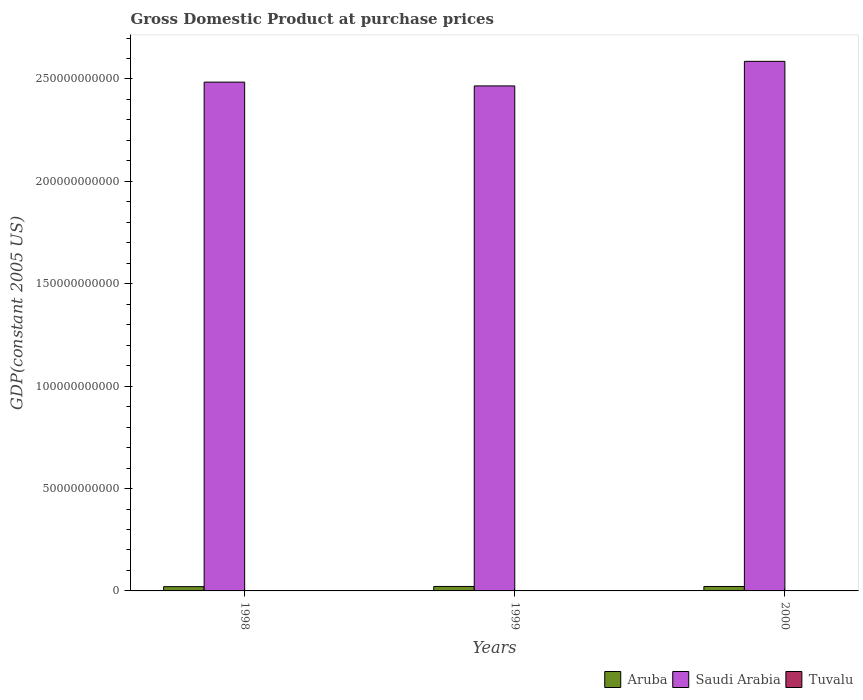What is the GDP at purchase prices in Saudi Arabia in 1998?
Offer a terse response. 2.48e+11. Across all years, what is the maximum GDP at purchase prices in Aruba?
Your response must be concise. 2.18e+09. Across all years, what is the minimum GDP at purchase prices in Aruba?
Give a very brief answer. 2.09e+09. What is the total GDP at purchase prices in Saudi Arabia in the graph?
Provide a succinct answer. 7.54e+11. What is the difference between the GDP at purchase prices in Aruba in 1998 and that in 1999?
Offer a terse response. -9.41e+07. What is the difference between the GDP at purchase prices in Saudi Arabia in 2000 and the GDP at purchase prices in Tuvalu in 1999?
Provide a succinct answer. 2.59e+11. What is the average GDP at purchase prices in Saudi Arabia per year?
Offer a terse response. 2.51e+11. In the year 1999, what is the difference between the GDP at purchase prices in Tuvalu and GDP at purchase prices in Saudi Arabia?
Your answer should be very brief. -2.47e+11. In how many years, is the GDP at purchase prices in Tuvalu greater than 110000000000 US$?
Provide a short and direct response. 0. What is the ratio of the GDP at purchase prices in Saudi Arabia in 1998 to that in 1999?
Make the answer very short. 1.01. Is the GDP at purchase prices in Aruba in 1999 less than that in 2000?
Offer a terse response. No. Is the difference between the GDP at purchase prices in Tuvalu in 1998 and 2000 greater than the difference between the GDP at purchase prices in Saudi Arabia in 1998 and 2000?
Give a very brief answer. Yes. What is the difference between the highest and the second highest GDP at purchase prices in Aruba?
Keep it short and to the point. 7.95e+06. What is the difference between the highest and the lowest GDP at purchase prices in Saudi Arabia?
Keep it short and to the point. 1.20e+1. In how many years, is the GDP at purchase prices in Aruba greater than the average GDP at purchase prices in Aruba taken over all years?
Provide a succinct answer. 2. What does the 3rd bar from the left in 1998 represents?
Your response must be concise. Tuvalu. What does the 2nd bar from the right in 2000 represents?
Offer a very short reply. Saudi Arabia. Is it the case that in every year, the sum of the GDP at purchase prices in Aruba and GDP at purchase prices in Saudi Arabia is greater than the GDP at purchase prices in Tuvalu?
Provide a short and direct response. Yes. How many years are there in the graph?
Give a very brief answer. 3. Are the values on the major ticks of Y-axis written in scientific E-notation?
Your answer should be compact. No. Does the graph contain grids?
Give a very brief answer. No. How are the legend labels stacked?
Offer a very short reply. Horizontal. What is the title of the graph?
Offer a very short reply. Gross Domestic Product at purchase prices. What is the label or title of the X-axis?
Ensure brevity in your answer.  Years. What is the label or title of the Y-axis?
Make the answer very short. GDP(constant 2005 US). What is the GDP(constant 2005 US) of Aruba in 1998?
Make the answer very short. 2.09e+09. What is the GDP(constant 2005 US) of Saudi Arabia in 1998?
Your answer should be compact. 2.48e+11. What is the GDP(constant 2005 US) in Tuvalu in 1998?
Make the answer very short. 2.23e+07. What is the GDP(constant 2005 US) of Aruba in 1999?
Ensure brevity in your answer.  2.18e+09. What is the GDP(constant 2005 US) of Saudi Arabia in 1999?
Offer a terse response. 2.47e+11. What is the GDP(constant 2005 US) in Tuvalu in 1999?
Offer a very short reply. 2.19e+07. What is the GDP(constant 2005 US) in Aruba in 2000?
Provide a short and direct response. 2.17e+09. What is the GDP(constant 2005 US) of Saudi Arabia in 2000?
Offer a terse response. 2.59e+11. What is the GDP(constant 2005 US) of Tuvalu in 2000?
Give a very brief answer. 2.17e+07. Across all years, what is the maximum GDP(constant 2005 US) of Aruba?
Provide a short and direct response. 2.18e+09. Across all years, what is the maximum GDP(constant 2005 US) in Saudi Arabia?
Ensure brevity in your answer.  2.59e+11. Across all years, what is the maximum GDP(constant 2005 US) in Tuvalu?
Provide a succinct answer. 2.23e+07. Across all years, what is the minimum GDP(constant 2005 US) of Aruba?
Provide a succinct answer. 2.09e+09. Across all years, what is the minimum GDP(constant 2005 US) of Saudi Arabia?
Offer a very short reply. 2.47e+11. Across all years, what is the minimum GDP(constant 2005 US) in Tuvalu?
Your response must be concise. 2.17e+07. What is the total GDP(constant 2005 US) in Aruba in the graph?
Keep it short and to the point. 6.44e+09. What is the total GDP(constant 2005 US) of Saudi Arabia in the graph?
Your answer should be compact. 7.54e+11. What is the total GDP(constant 2005 US) of Tuvalu in the graph?
Give a very brief answer. 6.59e+07. What is the difference between the GDP(constant 2005 US) of Aruba in 1998 and that in 1999?
Your response must be concise. -9.41e+07. What is the difference between the GDP(constant 2005 US) in Saudi Arabia in 1998 and that in 1999?
Offer a very short reply. 1.86e+09. What is the difference between the GDP(constant 2005 US) in Tuvalu in 1998 and that in 1999?
Your answer should be very brief. 3.48e+05. What is the difference between the GDP(constant 2005 US) of Aruba in 1998 and that in 2000?
Your response must be concise. -8.62e+07. What is the difference between the GDP(constant 2005 US) of Saudi Arabia in 1998 and that in 2000?
Ensure brevity in your answer.  -1.01e+1. What is the difference between the GDP(constant 2005 US) of Tuvalu in 1998 and that in 2000?
Your answer should be compact. 5.61e+05. What is the difference between the GDP(constant 2005 US) of Aruba in 1999 and that in 2000?
Make the answer very short. 7.95e+06. What is the difference between the GDP(constant 2005 US) of Saudi Arabia in 1999 and that in 2000?
Your answer should be very brief. -1.20e+1. What is the difference between the GDP(constant 2005 US) in Tuvalu in 1999 and that in 2000?
Your answer should be very brief. 2.13e+05. What is the difference between the GDP(constant 2005 US) of Aruba in 1998 and the GDP(constant 2005 US) of Saudi Arabia in 1999?
Offer a very short reply. -2.45e+11. What is the difference between the GDP(constant 2005 US) of Aruba in 1998 and the GDP(constant 2005 US) of Tuvalu in 1999?
Ensure brevity in your answer.  2.06e+09. What is the difference between the GDP(constant 2005 US) in Saudi Arabia in 1998 and the GDP(constant 2005 US) in Tuvalu in 1999?
Provide a short and direct response. 2.48e+11. What is the difference between the GDP(constant 2005 US) of Aruba in 1998 and the GDP(constant 2005 US) of Saudi Arabia in 2000?
Your answer should be compact. -2.57e+11. What is the difference between the GDP(constant 2005 US) in Aruba in 1998 and the GDP(constant 2005 US) in Tuvalu in 2000?
Your answer should be very brief. 2.06e+09. What is the difference between the GDP(constant 2005 US) in Saudi Arabia in 1998 and the GDP(constant 2005 US) in Tuvalu in 2000?
Your response must be concise. 2.48e+11. What is the difference between the GDP(constant 2005 US) of Aruba in 1999 and the GDP(constant 2005 US) of Saudi Arabia in 2000?
Make the answer very short. -2.56e+11. What is the difference between the GDP(constant 2005 US) of Aruba in 1999 and the GDP(constant 2005 US) of Tuvalu in 2000?
Provide a short and direct response. 2.16e+09. What is the difference between the GDP(constant 2005 US) in Saudi Arabia in 1999 and the GDP(constant 2005 US) in Tuvalu in 2000?
Your answer should be compact. 2.47e+11. What is the average GDP(constant 2005 US) of Aruba per year?
Provide a short and direct response. 2.15e+09. What is the average GDP(constant 2005 US) in Saudi Arabia per year?
Make the answer very short. 2.51e+11. What is the average GDP(constant 2005 US) of Tuvalu per year?
Give a very brief answer. 2.20e+07. In the year 1998, what is the difference between the GDP(constant 2005 US) of Aruba and GDP(constant 2005 US) of Saudi Arabia?
Your answer should be very brief. -2.46e+11. In the year 1998, what is the difference between the GDP(constant 2005 US) of Aruba and GDP(constant 2005 US) of Tuvalu?
Offer a terse response. 2.06e+09. In the year 1998, what is the difference between the GDP(constant 2005 US) in Saudi Arabia and GDP(constant 2005 US) in Tuvalu?
Your answer should be very brief. 2.48e+11. In the year 1999, what is the difference between the GDP(constant 2005 US) in Aruba and GDP(constant 2005 US) in Saudi Arabia?
Provide a succinct answer. -2.44e+11. In the year 1999, what is the difference between the GDP(constant 2005 US) of Aruba and GDP(constant 2005 US) of Tuvalu?
Offer a very short reply. 2.16e+09. In the year 1999, what is the difference between the GDP(constant 2005 US) of Saudi Arabia and GDP(constant 2005 US) of Tuvalu?
Ensure brevity in your answer.  2.47e+11. In the year 2000, what is the difference between the GDP(constant 2005 US) in Aruba and GDP(constant 2005 US) in Saudi Arabia?
Provide a short and direct response. -2.56e+11. In the year 2000, what is the difference between the GDP(constant 2005 US) of Aruba and GDP(constant 2005 US) of Tuvalu?
Provide a short and direct response. 2.15e+09. In the year 2000, what is the difference between the GDP(constant 2005 US) of Saudi Arabia and GDP(constant 2005 US) of Tuvalu?
Ensure brevity in your answer.  2.59e+11. What is the ratio of the GDP(constant 2005 US) in Aruba in 1998 to that in 1999?
Keep it short and to the point. 0.96. What is the ratio of the GDP(constant 2005 US) in Saudi Arabia in 1998 to that in 1999?
Provide a short and direct response. 1.01. What is the ratio of the GDP(constant 2005 US) in Tuvalu in 1998 to that in 1999?
Your answer should be very brief. 1.02. What is the ratio of the GDP(constant 2005 US) of Aruba in 1998 to that in 2000?
Offer a terse response. 0.96. What is the ratio of the GDP(constant 2005 US) in Saudi Arabia in 1998 to that in 2000?
Offer a very short reply. 0.96. What is the ratio of the GDP(constant 2005 US) of Tuvalu in 1998 to that in 2000?
Your answer should be very brief. 1.03. What is the ratio of the GDP(constant 2005 US) in Saudi Arabia in 1999 to that in 2000?
Provide a succinct answer. 0.95. What is the ratio of the GDP(constant 2005 US) in Tuvalu in 1999 to that in 2000?
Your answer should be very brief. 1.01. What is the difference between the highest and the second highest GDP(constant 2005 US) of Aruba?
Make the answer very short. 7.95e+06. What is the difference between the highest and the second highest GDP(constant 2005 US) of Saudi Arabia?
Offer a very short reply. 1.01e+1. What is the difference between the highest and the second highest GDP(constant 2005 US) of Tuvalu?
Your answer should be very brief. 3.48e+05. What is the difference between the highest and the lowest GDP(constant 2005 US) of Aruba?
Your answer should be compact. 9.41e+07. What is the difference between the highest and the lowest GDP(constant 2005 US) in Saudi Arabia?
Provide a succinct answer. 1.20e+1. What is the difference between the highest and the lowest GDP(constant 2005 US) in Tuvalu?
Provide a succinct answer. 5.61e+05. 